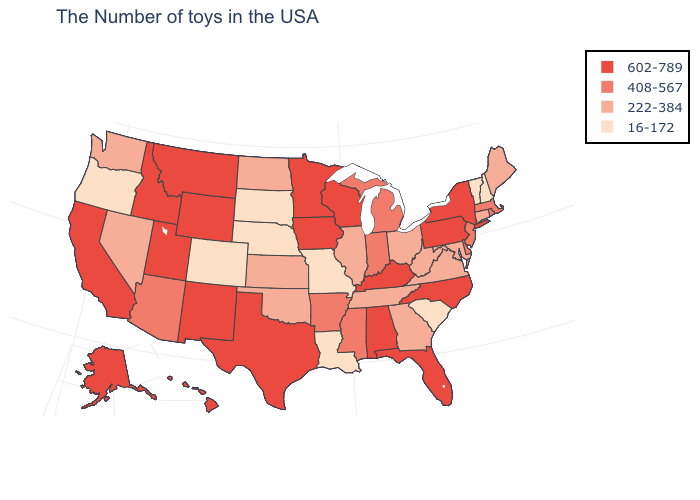What is the lowest value in states that border Montana?
Be succinct. 16-172. What is the value of New York?
Concise answer only. 602-789. Does the first symbol in the legend represent the smallest category?
Be succinct. No. Which states have the lowest value in the South?
Write a very short answer. South Carolina, Louisiana. Name the states that have a value in the range 222-384?
Short answer required. Maine, Connecticut, Maryland, Virginia, West Virginia, Ohio, Georgia, Tennessee, Illinois, Kansas, Oklahoma, North Dakota, Nevada, Washington. Does the map have missing data?
Keep it brief. No. Which states have the lowest value in the USA?
Give a very brief answer. New Hampshire, Vermont, South Carolina, Louisiana, Missouri, Nebraska, South Dakota, Colorado, Oregon. Name the states that have a value in the range 408-567?
Give a very brief answer. Massachusetts, Rhode Island, New Jersey, Delaware, Michigan, Indiana, Mississippi, Arkansas, Arizona. Does New Jersey have the lowest value in the USA?
Keep it brief. No. Does Wisconsin have the same value as South Carolina?
Answer briefly. No. What is the value of South Dakota?
Answer briefly. 16-172. Name the states that have a value in the range 408-567?
Answer briefly. Massachusetts, Rhode Island, New Jersey, Delaware, Michigan, Indiana, Mississippi, Arkansas, Arizona. What is the value of New Hampshire?
Keep it brief. 16-172. Which states have the highest value in the USA?
Concise answer only. New York, Pennsylvania, North Carolina, Florida, Kentucky, Alabama, Wisconsin, Minnesota, Iowa, Texas, Wyoming, New Mexico, Utah, Montana, Idaho, California, Alaska, Hawaii. Name the states that have a value in the range 222-384?
Keep it brief. Maine, Connecticut, Maryland, Virginia, West Virginia, Ohio, Georgia, Tennessee, Illinois, Kansas, Oklahoma, North Dakota, Nevada, Washington. 